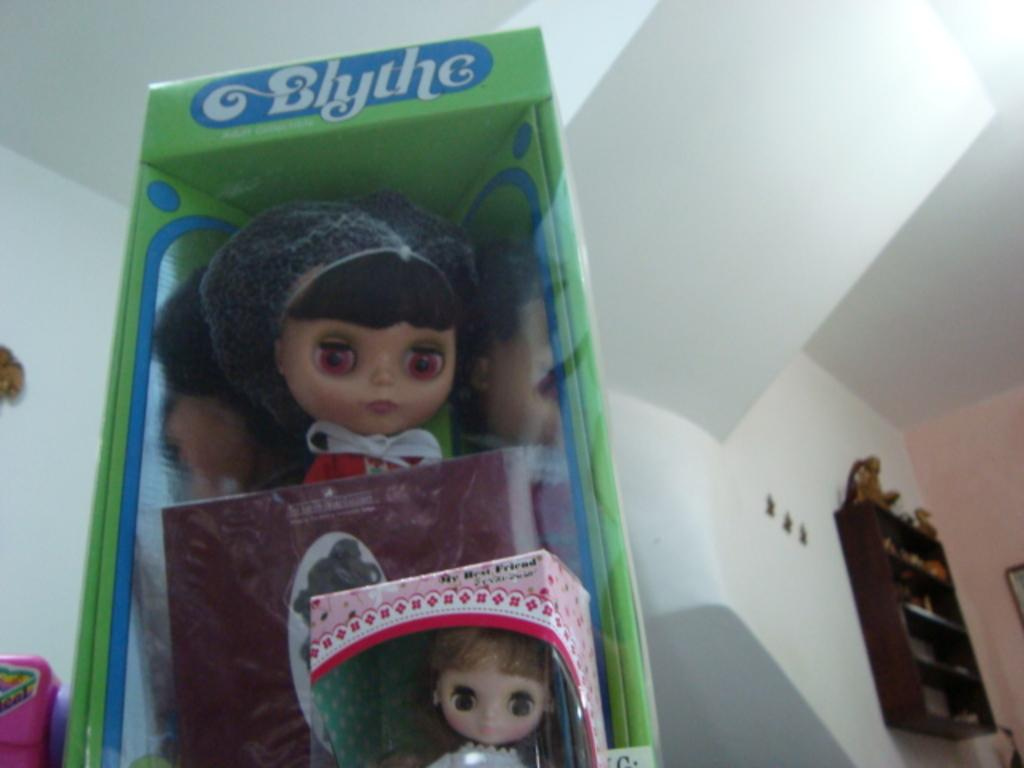What objects are present in the image? There are dolls in the image. How are the dolls arranged or stored? The dolls are packed in boxes. What color is the box containing the dolls? The box is green in color. What can be seen in the background of the image? There is a wall in the background of the image. What is located on the right side of the image? There is a shelf on the right side of the image. Can you describe the steam coming from the doll's head in the image? There is no steam coming from the doll's head in the image; the dolls are packed in boxes. 